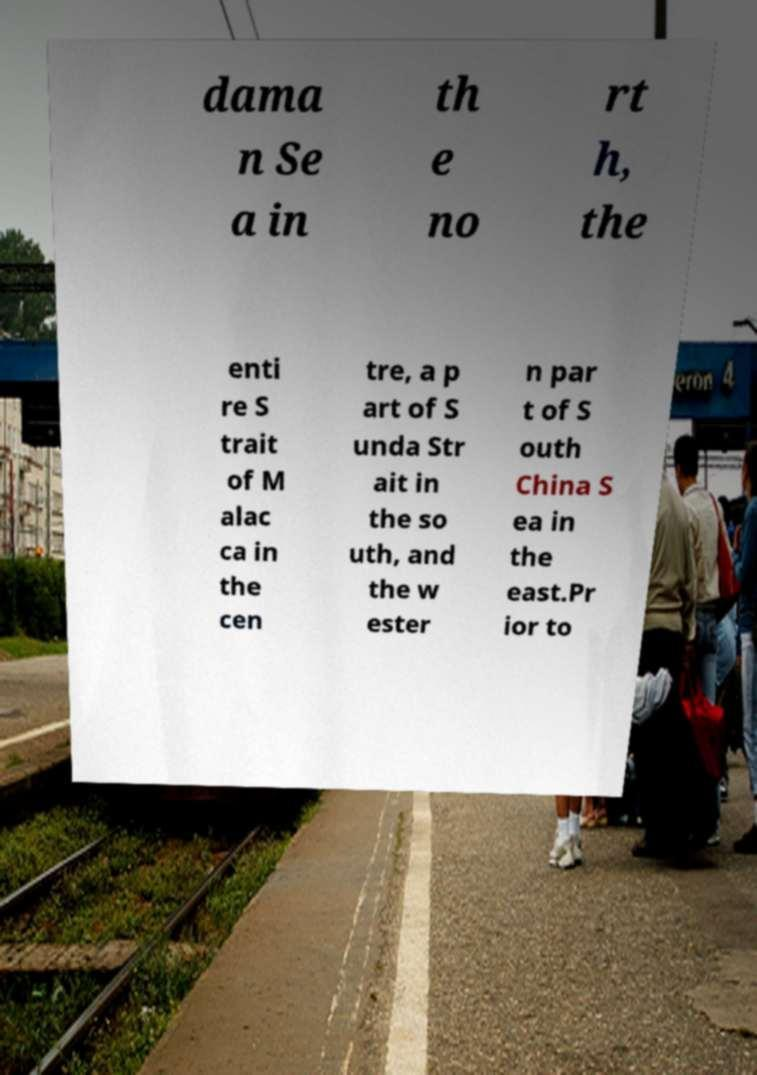Could you assist in decoding the text presented in this image and type it out clearly? dama n Se a in th e no rt h, the enti re S trait of M alac ca in the cen tre, a p art of S unda Str ait in the so uth, and the w ester n par t of S outh China S ea in the east.Pr ior to 